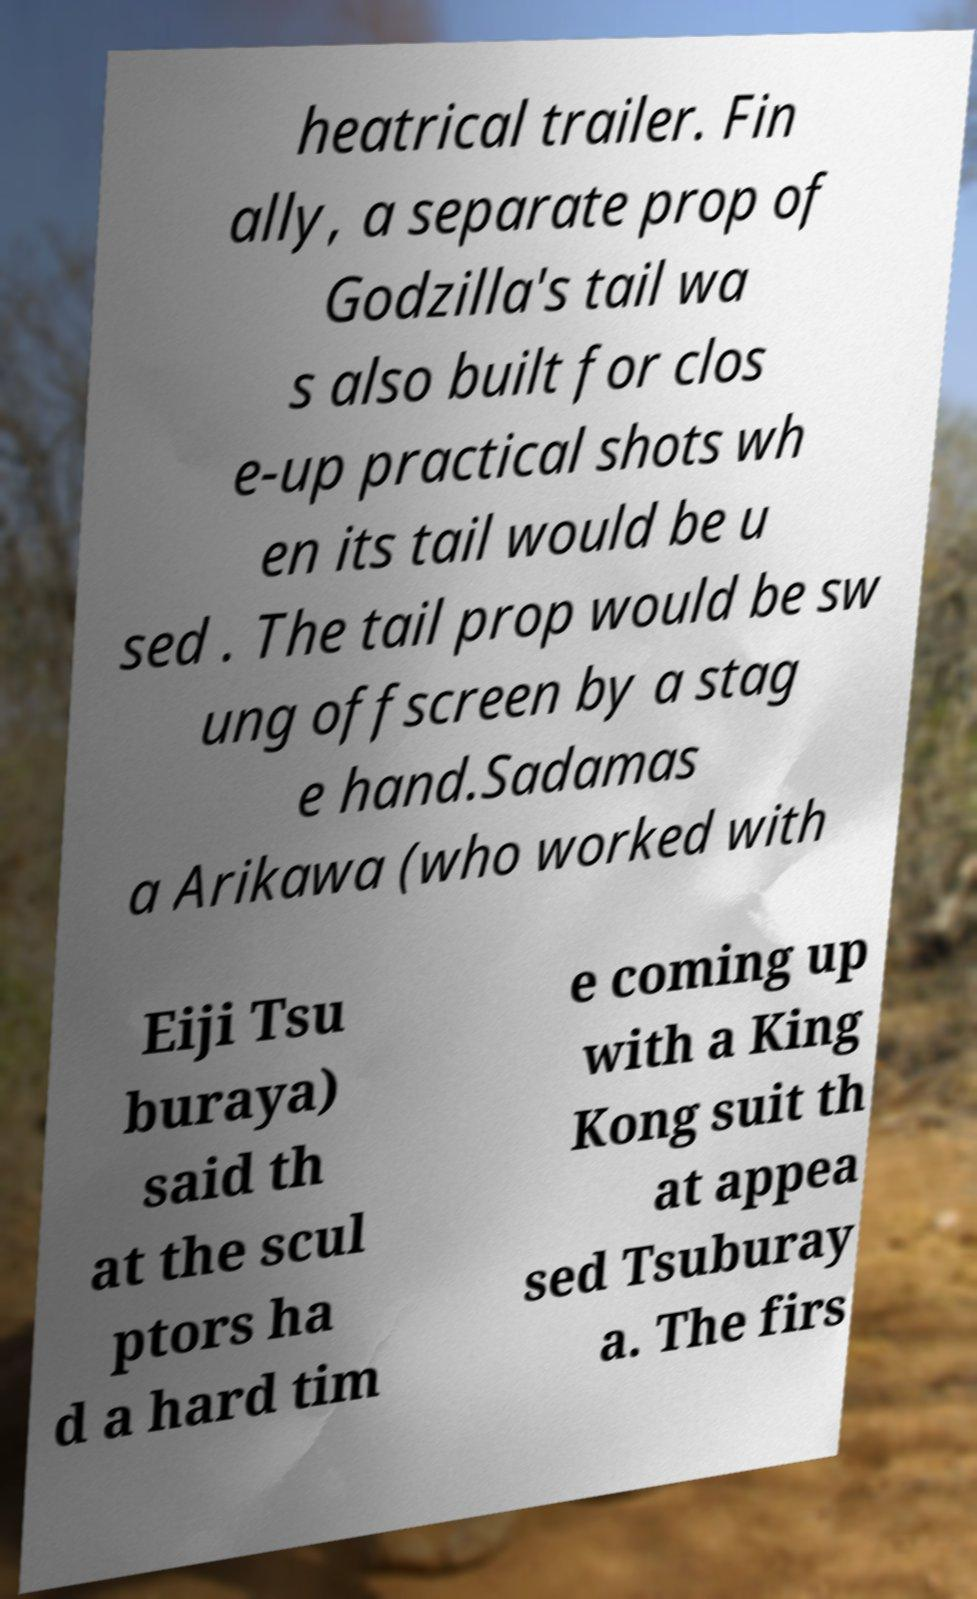Please read and relay the text visible in this image. What does it say? heatrical trailer. Fin ally, a separate prop of Godzilla's tail wa s also built for clos e-up practical shots wh en its tail would be u sed . The tail prop would be sw ung offscreen by a stag e hand.Sadamas a Arikawa (who worked with Eiji Tsu buraya) said th at the scul ptors ha d a hard tim e coming up with a King Kong suit th at appea sed Tsuburay a. The firs 